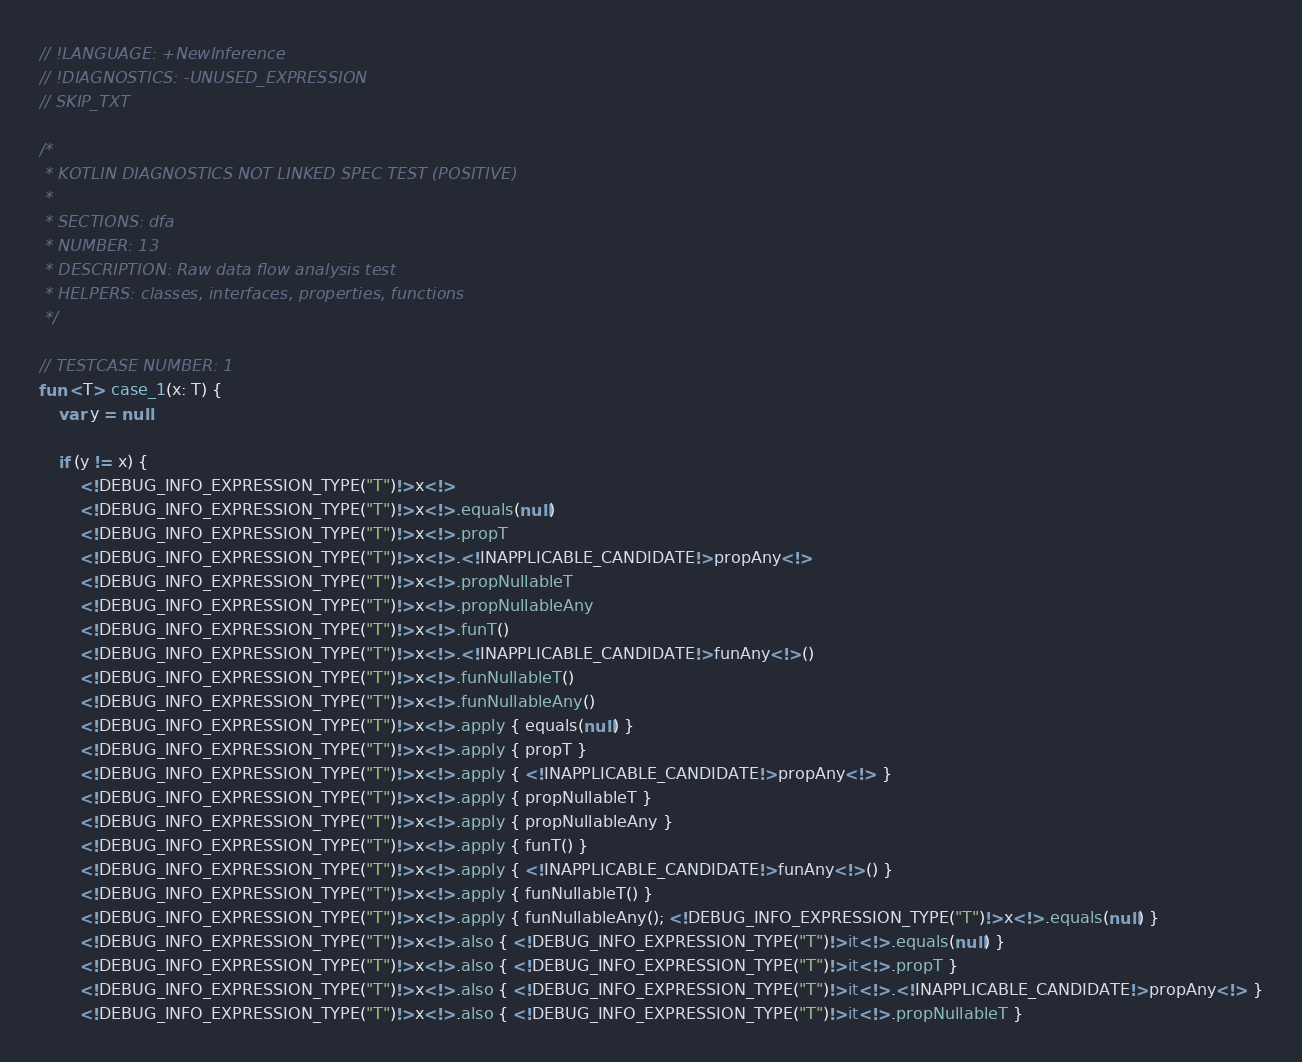<code> <loc_0><loc_0><loc_500><loc_500><_Kotlin_>// !LANGUAGE: +NewInference
// !DIAGNOSTICS: -UNUSED_EXPRESSION
// SKIP_TXT

/*
 * KOTLIN DIAGNOSTICS NOT LINKED SPEC TEST (POSITIVE)
 *
 * SECTIONS: dfa
 * NUMBER: 13
 * DESCRIPTION: Raw data flow analysis test
 * HELPERS: classes, interfaces, properties, functions
 */

// TESTCASE NUMBER: 1
fun <T> case_1(x: T) {
    var y = null

    if (y != x) {
        <!DEBUG_INFO_EXPRESSION_TYPE("T")!>x<!>
        <!DEBUG_INFO_EXPRESSION_TYPE("T")!>x<!>.equals(null)
        <!DEBUG_INFO_EXPRESSION_TYPE("T")!>x<!>.propT
        <!DEBUG_INFO_EXPRESSION_TYPE("T")!>x<!>.<!INAPPLICABLE_CANDIDATE!>propAny<!>
        <!DEBUG_INFO_EXPRESSION_TYPE("T")!>x<!>.propNullableT
        <!DEBUG_INFO_EXPRESSION_TYPE("T")!>x<!>.propNullableAny
        <!DEBUG_INFO_EXPRESSION_TYPE("T")!>x<!>.funT()
        <!DEBUG_INFO_EXPRESSION_TYPE("T")!>x<!>.<!INAPPLICABLE_CANDIDATE!>funAny<!>()
        <!DEBUG_INFO_EXPRESSION_TYPE("T")!>x<!>.funNullableT()
        <!DEBUG_INFO_EXPRESSION_TYPE("T")!>x<!>.funNullableAny()
        <!DEBUG_INFO_EXPRESSION_TYPE("T")!>x<!>.apply { equals(null) }
        <!DEBUG_INFO_EXPRESSION_TYPE("T")!>x<!>.apply { propT }
        <!DEBUG_INFO_EXPRESSION_TYPE("T")!>x<!>.apply { <!INAPPLICABLE_CANDIDATE!>propAny<!> }
        <!DEBUG_INFO_EXPRESSION_TYPE("T")!>x<!>.apply { propNullableT }
        <!DEBUG_INFO_EXPRESSION_TYPE("T")!>x<!>.apply { propNullableAny }
        <!DEBUG_INFO_EXPRESSION_TYPE("T")!>x<!>.apply { funT() }
        <!DEBUG_INFO_EXPRESSION_TYPE("T")!>x<!>.apply { <!INAPPLICABLE_CANDIDATE!>funAny<!>() }
        <!DEBUG_INFO_EXPRESSION_TYPE("T")!>x<!>.apply { funNullableT() }
        <!DEBUG_INFO_EXPRESSION_TYPE("T")!>x<!>.apply { funNullableAny(); <!DEBUG_INFO_EXPRESSION_TYPE("T")!>x<!>.equals(null) }
        <!DEBUG_INFO_EXPRESSION_TYPE("T")!>x<!>.also { <!DEBUG_INFO_EXPRESSION_TYPE("T")!>it<!>.equals(null) }
        <!DEBUG_INFO_EXPRESSION_TYPE("T")!>x<!>.also { <!DEBUG_INFO_EXPRESSION_TYPE("T")!>it<!>.propT }
        <!DEBUG_INFO_EXPRESSION_TYPE("T")!>x<!>.also { <!DEBUG_INFO_EXPRESSION_TYPE("T")!>it<!>.<!INAPPLICABLE_CANDIDATE!>propAny<!> }
        <!DEBUG_INFO_EXPRESSION_TYPE("T")!>x<!>.also { <!DEBUG_INFO_EXPRESSION_TYPE("T")!>it<!>.propNullableT }</code> 